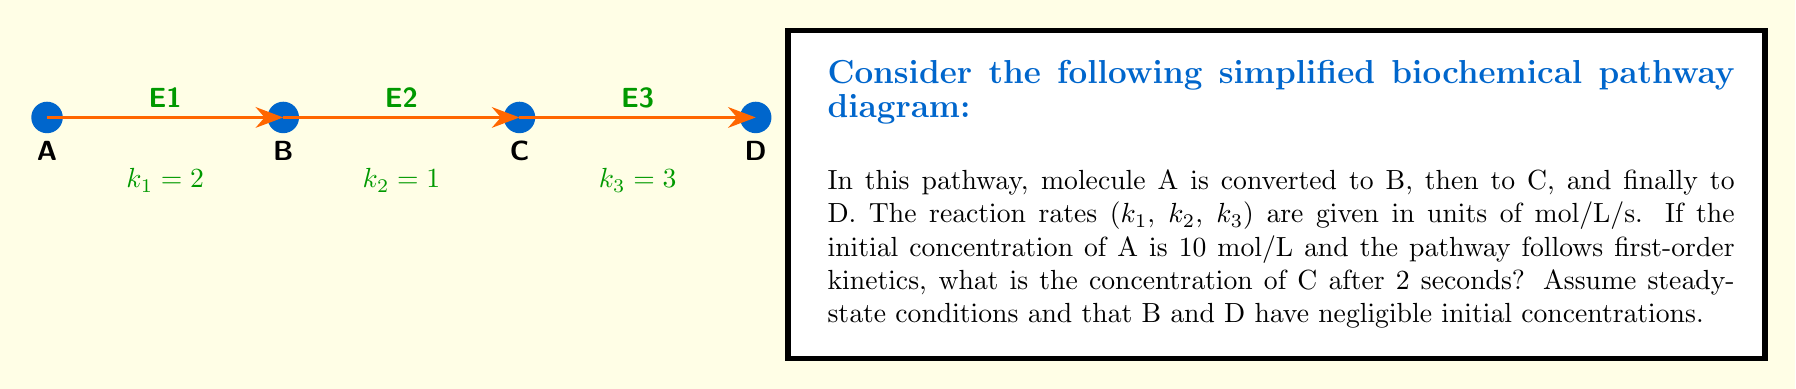Provide a solution to this math problem. To solve this problem, we need to use the principles of enzyme kinetics and steady-state approximation. Let's approach this step-by-step:

1) In steady-state conditions, the rate of formation of an intermediate is equal to its rate of consumption. For molecule C:

   Rate of formation = Rate of consumption
   $k_2[B] = k_3[C]$

2) Similarly, for molecule B:
   $k_1[A] = k_2[B]$

3) From the given information:
   $k_1 = 2$ mol/L/s
   $k_2 = 1$ mol/L/s
   $k_3 = 3$ mol/L/s
   $[A]_0 = 10$ mol/L

4) For first-order kinetics, the concentration of A at time t is given by:
   $[A]_t = [A]_0 e^{-k_1t}$

5) After 2 seconds:
   $[A]_2 = 10 e^{-2(2)} = 10 e^{-4} \approx 0.1832$ mol/L

6) Now, we can use the steady-state equations:
   $k_1[A] = k_2[B]$
   $2(0.1832) = 1[B]$
   $[B] = 0.3664$ mol/L

7) And:
   $k_2[B] = k_3[C]$
   $1(0.3664) = 3[C]$
   $[C] = 0.1221$ mol/L

Therefore, the concentration of C after 2 seconds is approximately 0.1221 mol/L.
Answer: 0.1221 mol/L 